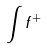<formula> <loc_0><loc_0><loc_500><loc_500>\int f ^ { + }</formula> 